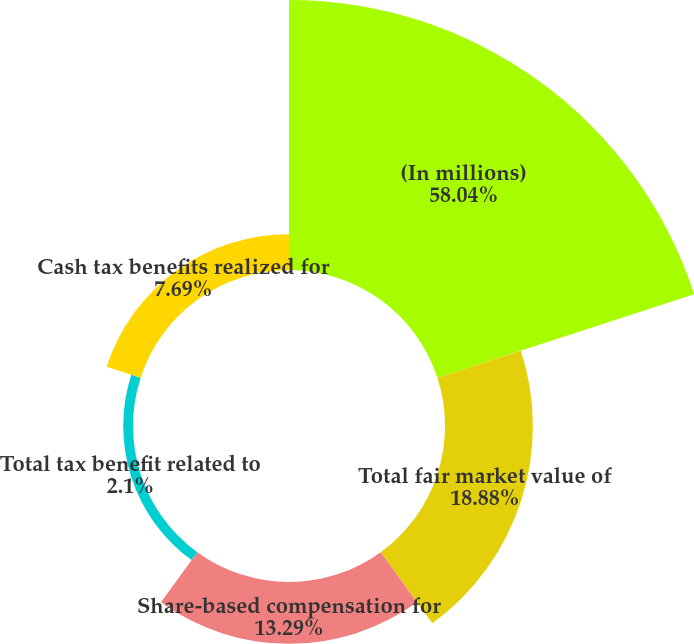<chart> <loc_0><loc_0><loc_500><loc_500><pie_chart><fcel>(In millions)<fcel>Total fair market value of<fcel>Share-based compensation for<fcel>Total tax benefit related to<fcel>Cash tax benefits realized for<nl><fcel>58.03%<fcel>18.88%<fcel>13.29%<fcel>2.1%<fcel>7.69%<nl></chart> 